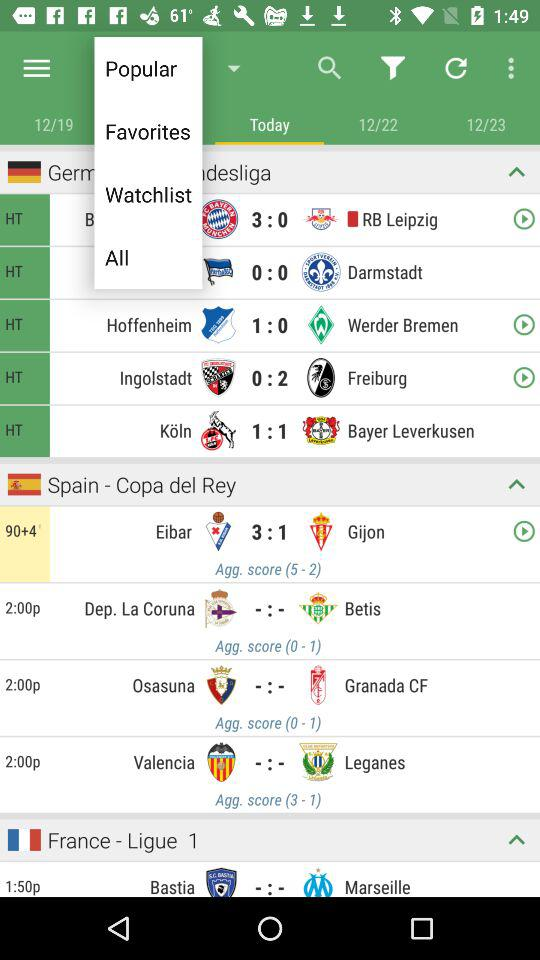What's the game time? The time of the game is 12:00 p.m. 